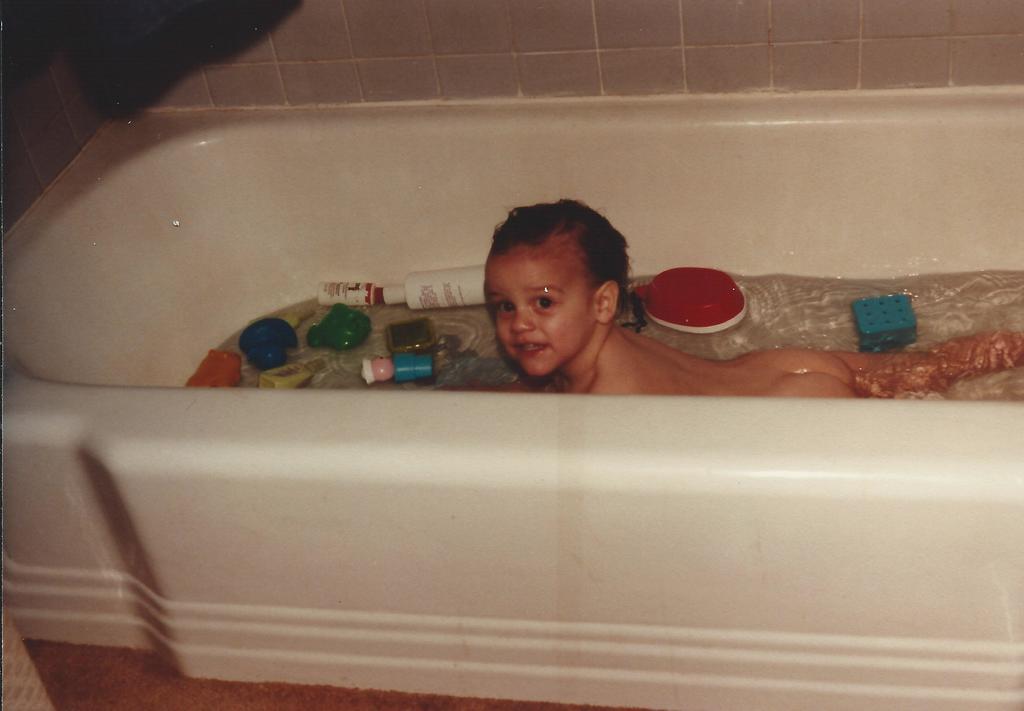Describe this image in one or two sentences. In this image I see the bathtub and I see a baby in the water and I see few things and I see the marble wall in the background and I see that it is black over here. 